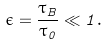Convert formula to latex. <formula><loc_0><loc_0><loc_500><loc_500>\epsilon = \frac { \tau _ { B } } { \tau _ { 0 } } \ll 1 .</formula> 